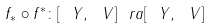Convert formula to latex. <formula><loc_0><loc_0><loc_500><loc_500>f _ { \ast } \circ f ^ { \ast } \colon [ \ Y , \ V ] \ r a [ \ Y , \ V ]</formula> 